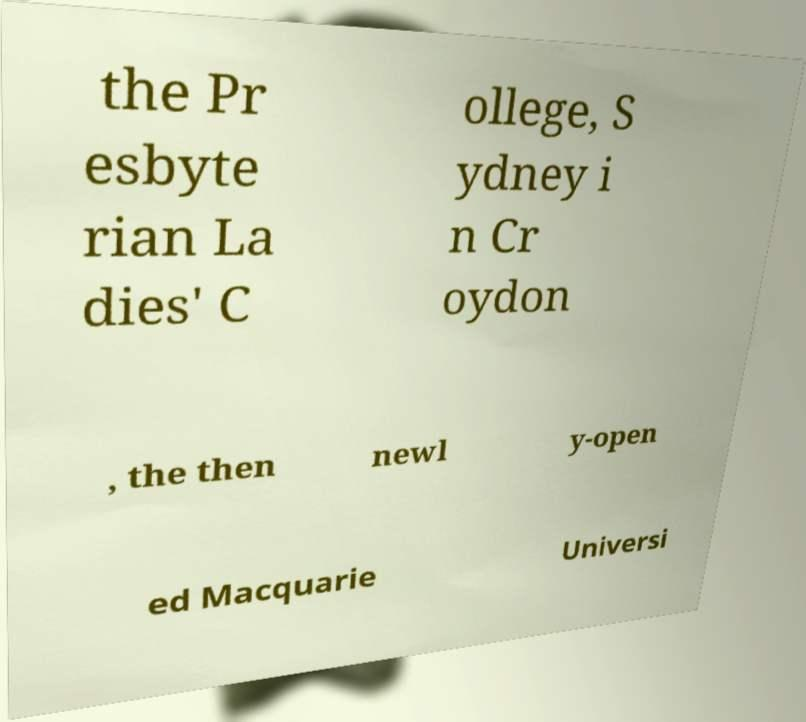Can you accurately transcribe the text from the provided image for me? the Pr esbyte rian La dies' C ollege, S ydney i n Cr oydon , the then newl y-open ed Macquarie Universi 